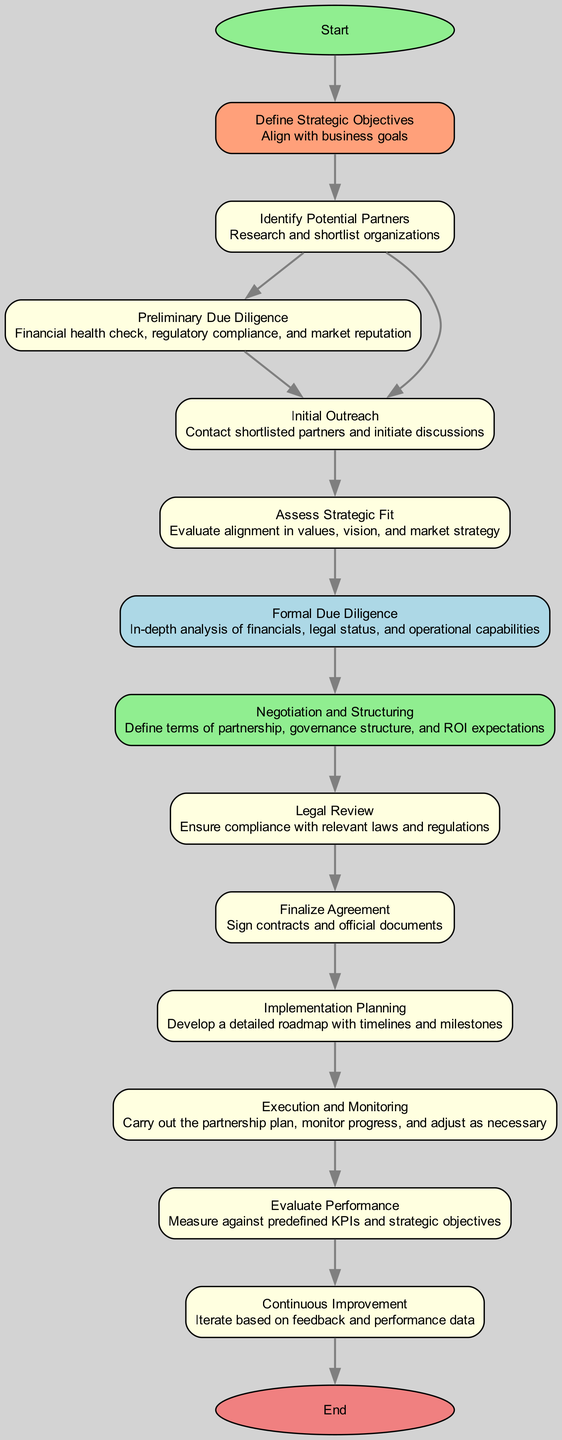What is the starting point of the flow chart? The flow chart begins with the node labeled "Define Strategic Objectives." This is the first action in the sequence, initiating the process.
Answer: Define Strategic Objectives How many steps are there from the "Identify Potential Partners" node to the "Evaluate Performance" node? Starting from "Identify Potential Partners," the process flows through several steps: "Preliminary Due Diligence," "Initial Outreach," "Assess Strategic Fit," "Formal Due Diligence," "Negotiation and Structuring," "Legal Review," "Finalize Agreement," "Implementation Planning," "Execution and Monitoring," and finally "Evaluate Performance." Counting these gives a total of eight steps.
Answer: 8 What action is taken immediately after "Formal Due Diligence"? The action that follows "Formal Due Diligence" is "Negotiation and Structuring." It directly leads to the next step in the process flow.
Answer: Negotiation and Structuring What is the action associated with the "Continuous Improvement" node? The action linked to the "Continuous Improvement" node is iterating based on feedback and performance data, a crucial final step in the evaluation process.
Answer: Iterate based on feedback and performance data What are the last two steps in the flow chart? The last two steps are "Evaluate Performance" followed by "Continuous Improvement." They represent the concluding actions of the partnership evaluation process.
Answer: Evaluate Performance, Continuous Improvement Which node does "Initial Outreach" lead to? "Initial Outreach" leads to "Assess Strategic Fit." This action follows the initial contact with potential partners and evaluates their strategic alignment.
Answer: Assess Strategic Fit What is the final outcome of the strategic partnership process? The final outcome is represented by the "End" node, which signifies a review of the strategic partnership process and its outcomes.
Answer: Review strategic partnership process and outcomes How many actions are listed in the "Implementation Planning" step? The "Implementation Planning" step encompasses the action of developing a detailed roadmap with timelines and milestones. This is a singular action but crucial for the execution phase.
Answer: Develop a detailed roadmap with timelines and milestones 